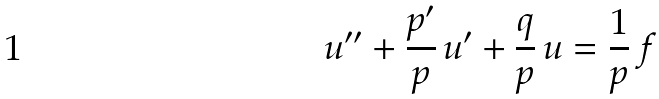<formula> <loc_0><loc_0><loc_500><loc_500>u ^ { \prime \prime } + \frac { p ^ { \prime } } { p } \, u ^ { \prime } + \frac { q } { p } \, u = \frac { 1 } { p } \, f</formula> 